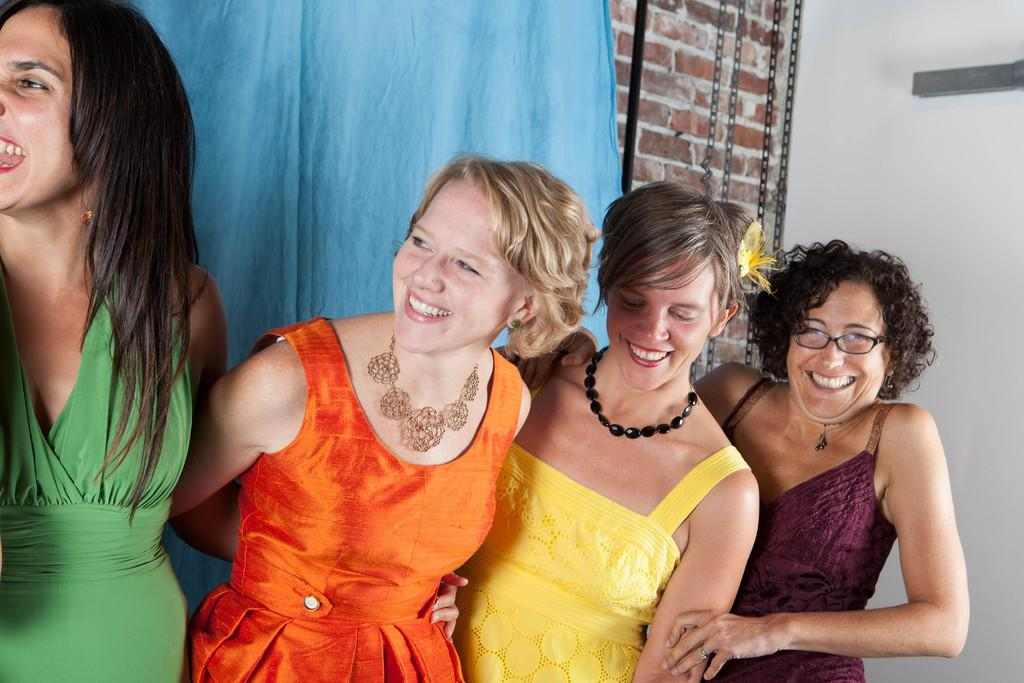How many people are present in the image? There are four ladies in the image. What is visible behind the ladies? There is a cloth visible behind the ladies. What is located behind the cloth? There is a wall behind the cloth. Can you see any sea creatures swimming in the image? There is no sea or sea creatures present in the image; it features four ladies and a cloth with a wall behind it. 